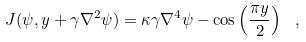<formula> <loc_0><loc_0><loc_500><loc_500>J ( \psi , y + \gamma \nabla ^ { 2 } \psi ) = \kappa \gamma \nabla ^ { 4 } \psi - \cos \left ( \frac { \pi y } { 2 } \right ) \ ,</formula> 